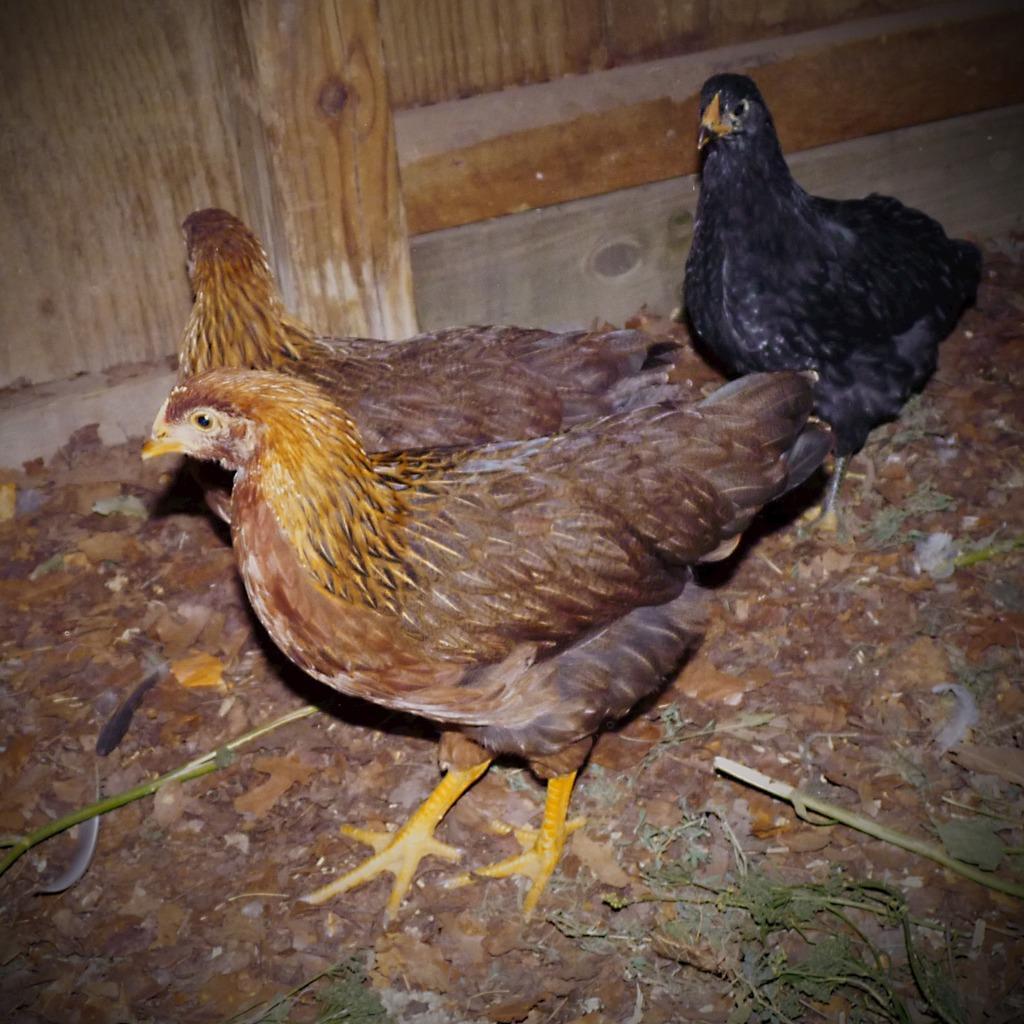Please provide a concise description of this image. In the image there are three hens and behind the hens there is a wooden surface. 